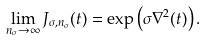<formula> <loc_0><loc_0><loc_500><loc_500>\lim _ { n _ { \sigma } \rightarrow \infty } J _ { \sigma , n _ { \sigma } } ( t ) = \exp \left ( \sigma \nabla ^ { 2 } ( t ) \right ) .</formula> 